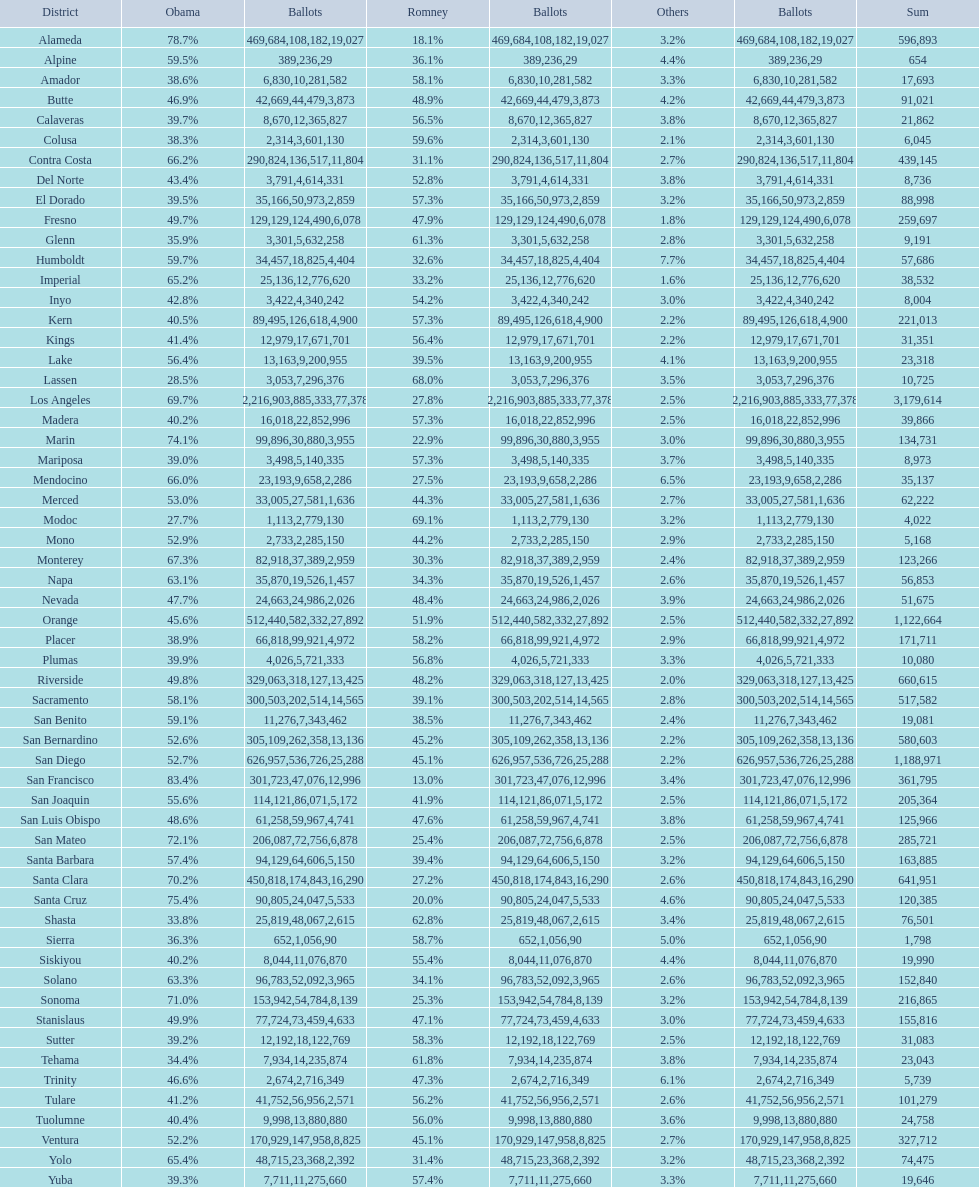What is the total number of votes for amador? 17693. Could you help me parse every detail presented in this table? {'header': ['District', 'Obama', 'Ballots', 'Romney', 'Ballots', 'Others', 'Ballots', 'Sum'], 'rows': [['Alameda', '78.7%', '469,684', '18.1%', '108,182', '3.2%', '19,027', '596,893'], ['Alpine', '59.5%', '389', '36.1%', '236', '4.4%', '29', '654'], ['Amador', '38.6%', '6,830', '58.1%', '10,281', '3.3%', '582', '17,693'], ['Butte', '46.9%', '42,669', '48.9%', '44,479', '4.2%', '3,873', '91,021'], ['Calaveras', '39.7%', '8,670', '56.5%', '12,365', '3.8%', '827', '21,862'], ['Colusa', '38.3%', '2,314', '59.6%', '3,601', '2.1%', '130', '6,045'], ['Contra Costa', '66.2%', '290,824', '31.1%', '136,517', '2.7%', '11,804', '439,145'], ['Del Norte', '43.4%', '3,791', '52.8%', '4,614', '3.8%', '331', '8,736'], ['El Dorado', '39.5%', '35,166', '57.3%', '50,973', '3.2%', '2,859', '88,998'], ['Fresno', '49.7%', '129,129', '47.9%', '124,490', '1.8%', '6,078', '259,697'], ['Glenn', '35.9%', '3,301', '61.3%', '5,632', '2.8%', '258', '9,191'], ['Humboldt', '59.7%', '34,457', '32.6%', '18,825', '7.7%', '4,404', '57,686'], ['Imperial', '65.2%', '25,136', '33.2%', '12,776', '1.6%', '620', '38,532'], ['Inyo', '42.8%', '3,422', '54.2%', '4,340', '3.0%', '242', '8,004'], ['Kern', '40.5%', '89,495', '57.3%', '126,618', '2.2%', '4,900', '221,013'], ['Kings', '41.4%', '12,979', '56.4%', '17,671', '2.2%', '701', '31,351'], ['Lake', '56.4%', '13,163', '39.5%', '9,200', '4.1%', '955', '23,318'], ['Lassen', '28.5%', '3,053', '68.0%', '7,296', '3.5%', '376', '10,725'], ['Los Angeles', '69.7%', '2,216,903', '27.8%', '885,333', '2.5%', '77,378', '3,179,614'], ['Madera', '40.2%', '16,018', '57.3%', '22,852', '2.5%', '996', '39,866'], ['Marin', '74.1%', '99,896', '22.9%', '30,880', '3.0%', '3,955', '134,731'], ['Mariposa', '39.0%', '3,498', '57.3%', '5,140', '3.7%', '335', '8,973'], ['Mendocino', '66.0%', '23,193', '27.5%', '9,658', '6.5%', '2,286', '35,137'], ['Merced', '53.0%', '33,005', '44.3%', '27,581', '2.7%', '1,636', '62,222'], ['Modoc', '27.7%', '1,113', '69.1%', '2,779', '3.2%', '130', '4,022'], ['Mono', '52.9%', '2,733', '44.2%', '2,285', '2.9%', '150', '5,168'], ['Monterey', '67.3%', '82,918', '30.3%', '37,389', '2.4%', '2,959', '123,266'], ['Napa', '63.1%', '35,870', '34.3%', '19,526', '2.6%', '1,457', '56,853'], ['Nevada', '47.7%', '24,663', '48.4%', '24,986', '3.9%', '2,026', '51,675'], ['Orange', '45.6%', '512,440', '51.9%', '582,332', '2.5%', '27,892', '1,122,664'], ['Placer', '38.9%', '66,818', '58.2%', '99,921', '2.9%', '4,972', '171,711'], ['Plumas', '39.9%', '4,026', '56.8%', '5,721', '3.3%', '333', '10,080'], ['Riverside', '49.8%', '329,063', '48.2%', '318,127', '2.0%', '13,425', '660,615'], ['Sacramento', '58.1%', '300,503', '39.1%', '202,514', '2.8%', '14,565', '517,582'], ['San Benito', '59.1%', '11,276', '38.5%', '7,343', '2.4%', '462', '19,081'], ['San Bernardino', '52.6%', '305,109', '45.2%', '262,358', '2.2%', '13,136', '580,603'], ['San Diego', '52.7%', '626,957', '45.1%', '536,726', '2.2%', '25,288', '1,188,971'], ['San Francisco', '83.4%', '301,723', '13.0%', '47,076', '3.4%', '12,996', '361,795'], ['San Joaquin', '55.6%', '114,121', '41.9%', '86,071', '2.5%', '5,172', '205,364'], ['San Luis Obispo', '48.6%', '61,258', '47.6%', '59,967', '3.8%', '4,741', '125,966'], ['San Mateo', '72.1%', '206,087', '25.4%', '72,756', '2.5%', '6,878', '285,721'], ['Santa Barbara', '57.4%', '94,129', '39.4%', '64,606', '3.2%', '5,150', '163,885'], ['Santa Clara', '70.2%', '450,818', '27.2%', '174,843', '2.6%', '16,290', '641,951'], ['Santa Cruz', '75.4%', '90,805', '20.0%', '24,047', '4.6%', '5,533', '120,385'], ['Shasta', '33.8%', '25,819', '62.8%', '48,067', '3.4%', '2,615', '76,501'], ['Sierra', '36.3%', '652', '58.7%', '1,056', '5.0%', '90', '1,798'], ['Siskiyou', '40.2%', '8,044', '55.4%', '11,076', '4.4%', '870', '19,990'], ['Solano', '63.3%', '96,783', '34.1%', '52,092', '2.6%', '3,965', '152,840'], ['Sonoma', '71.0%', '153,942', '25.3%', '54,784', '3.2%', '8,139', '216,865'], ['Stanislaus', '49.9%', '77,724', '47.1%', '73,459', '3.0%', '4,633', '155,816'], ['Sutter', '39.2%', '12,192', '58.3%', '18,122', '2.5%', '769', '31,083'], ['Tehama', '34.4%', '7,934', '61.8%', '14,235', '3.8%', '874', '23,043'], ['Trinity', '46.6%', '2,674', '47.3%', '2,716', '6.1%', '349', '5,739'], ['Tulare', '41.2%', '41,752', '56.2%', '56,956', '2.6%', '2,571', '101,279'], ['Tuolumne', '40.4%', '9,998', '56.0%', '13,880', '3.6%', '880', '24,758'], ['Ventura', '52.2%', '170,929', '45.1%', '147,958', '2.7%', '8,825', '327,712'], ['Yolo', '65.4%', '48,715', '31.4%', '23,368', '3.2%', '2,392', '74,475'], ['Yuba', '39.3%', '7,711', '57.4%', '11,275', '3.3%', '660', '19,646']]} 